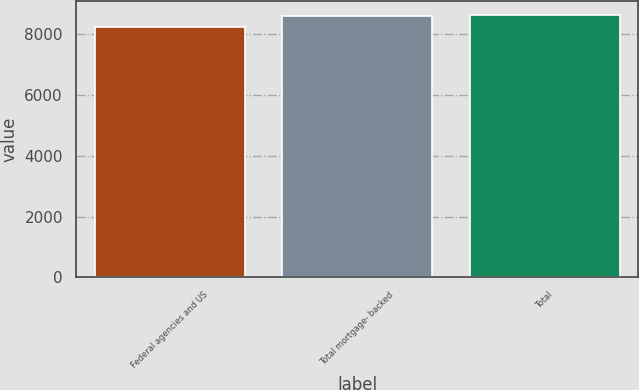Convert chart to OTSL. <chart><loc_0><loc_0><loc_500><loc_500><bar_chart><fcel>Federal agencies and US<fcel>Total mortgage- backed<fcel>Total<nl><fcel>8242<fcel>8612<fcel>8651.4<nl></chart> 